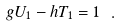Convert formula to latex. <formula><loc_0><loc_0><loc_500><loc_500>g U _ { 1 } - h T _ { 1 } = 1 \ .</formula> 